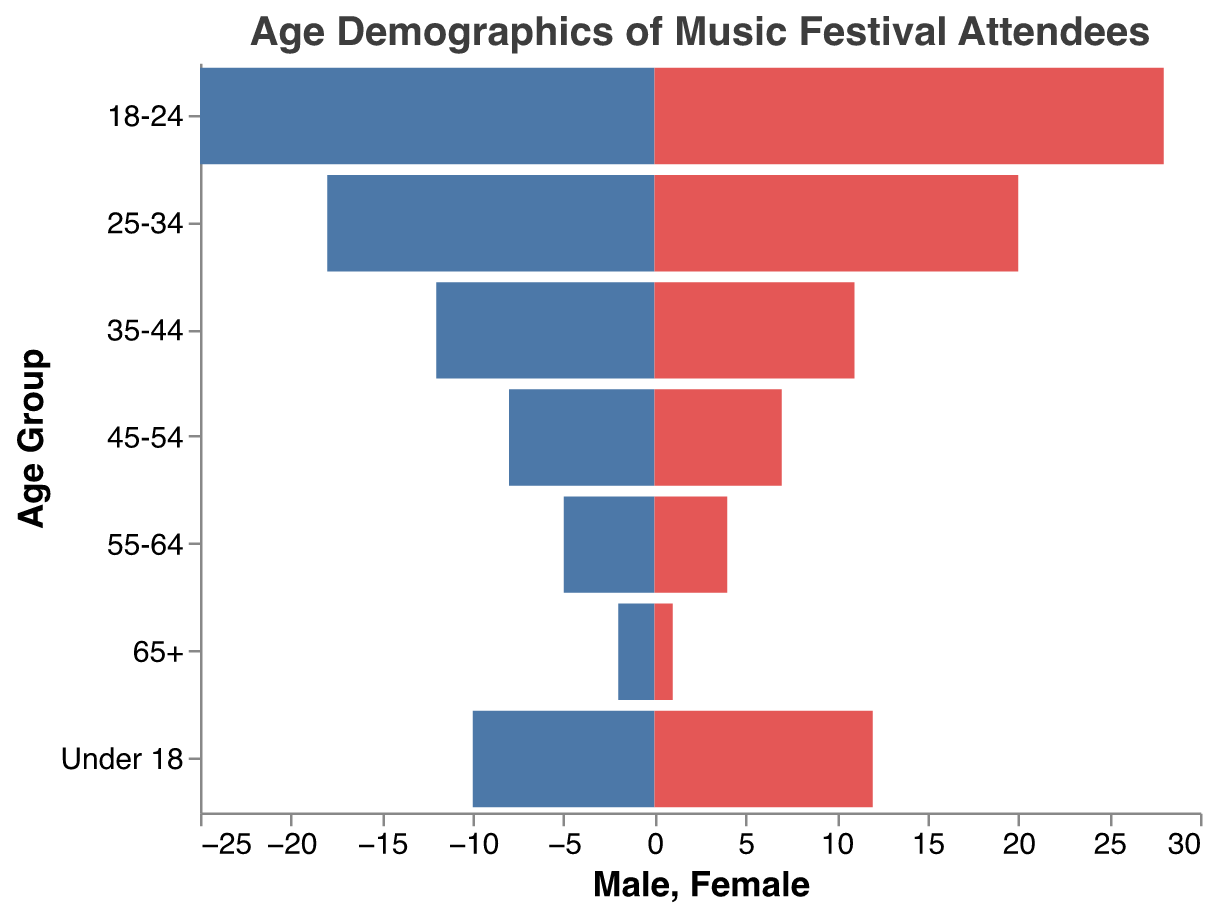what is the title of the figure? The title is located at the top of the figure. It reads "Age Demographics of Music Festival Attendees".
Answer: Age Demographics of Music Festival Attendees Which age group has the highest number of female attendees? By comparing the female bars across all age groups, the "18-24" age group has the longest bar representing female attendees.
Answer: 18-24 How many male attendees are there in the 55-64 age group? Identify the bar for males in the "55-64" age group and look at the value. The bar is associated with the value 5.
Answer: 5 What is the total number of male attendees for the 25-34 and 35-44 age groups combined? Sum the number of male attendees for 25-34 (18) and 35-44 (12). 18 + 12 = 30.
Answer: 30 Which gender has more attendees in the Under 18 age group? Compare the lengths of the bars for males (10) and females (12) in the "Under 18" age group. The female bar is longer.
Answer: Female What is the difference in the number of male and female attendees in the 18-24 age group? Subtract the number of female attendees (28) from the number of male attendees (25) in the 18-24 age group. 28 - 25 = 3.
Answer: 3 How does the number of attendees in the 65+ age group compare to the 45-54 age group for males? Compare the values for males in 65+ (2) and 45-54 (8). 45-54 has more male attendees than 65+.
Answer: 45-54 Which age group has the smallest overall attendance? Sum the male and female attendees for each age group and find the smallest total. 65+ has the smallest overall attendance with 2 males + 1 female = 3.
Answer: 65+ Between which two consecutive age groups is the change in female attendees the greatest? Calculate the differences in female attendees between consecutive age groups: 65+-55-64 (1-4), 55-64-45-54 (4-7), 45-54-35-44 (7-11), 35-44-25-34 (11-20), 25-34-18-24 (20-28), 18-24-Under 18 (28-12). The greatest change is between "Under 18" (12) and "18-24" (28) with a difference of 16.
Answer: Under 18 and 18-24 